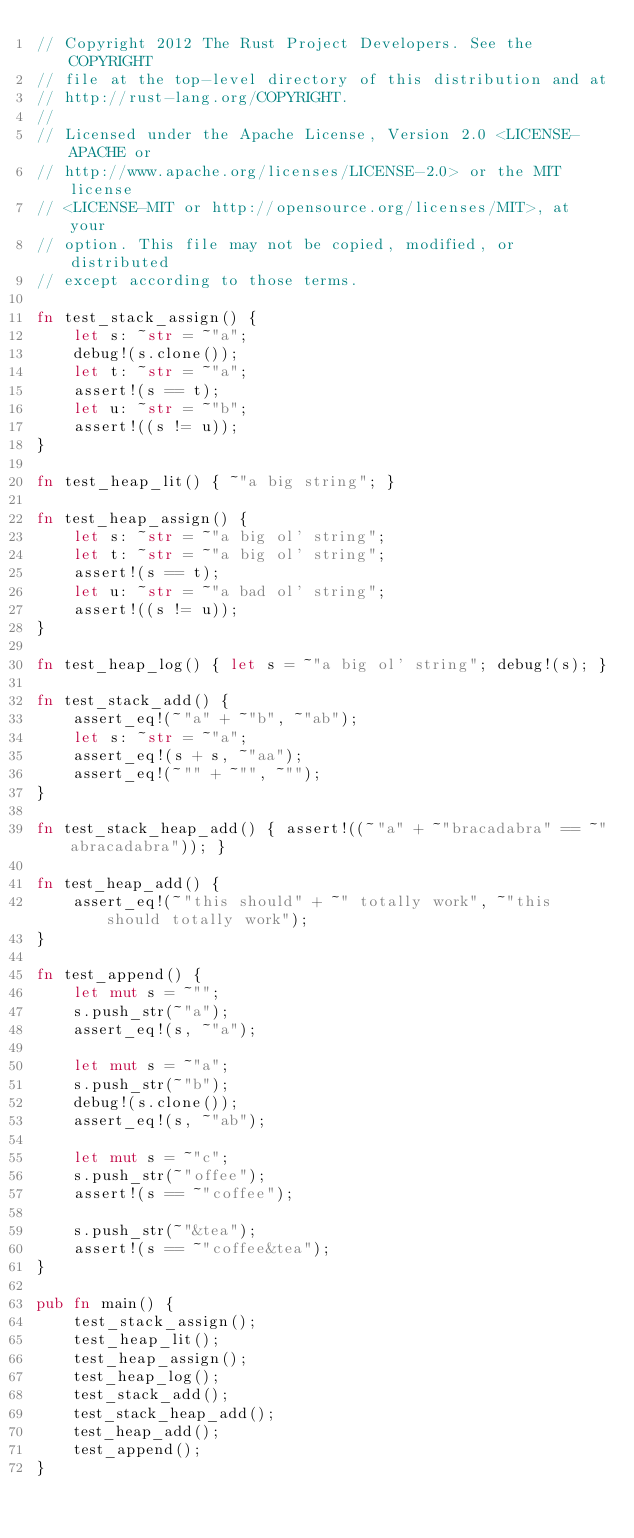Convert code to text. <code><loc_0><loc_0><loc_500><loc_500><_Rust_>// Copyright 2012 The Rust Project Developers. See the COPYRIGHT
// file at the top-level directory of this distribution and at
// http://rust-lang.org/COPYRIGHT.
//
// Licensed under the Apache License, Version 2.0 <LICENSE-APACHE or
// http://www.apache.org/licenses/LICENSE-2.0> or the MIT license
// <LICENSE-MIT or http://opensource.org/licenses/MIT>, at your
// option. This file may not be copied, modified, or distributed
// except according to those terms.

fn test_stack_assign() {
    let s: ~str = ~"a";
    debug!(s.clone());
    let t: ~str = ~"a";
    assert!(s == t);
    let u: ~str = ~"b";
    assert!((s != u));
}

fn test_heap_lit() { ~"a big string"; }

fn test_heap_assign() {
    let s: ~str = ~"a big ol' string";
    let t: ~str = ~"a big ol' string";
    assert!(s == t);
    let u: ~str = ~"a bad ol' string";
    assert!((s != u));
}

fn test_heap_log() { let s = ~"a big ol' string"; debug!(s); }

fn test_stack_add() {
    assert_eq!(~"a" + ~"b", ~"ab");
    let s: ~str = ~"a";
    assert_eq!(s + s, ~"aa");
    assert_eq!(~"" + ~"", ~"");
}

fn test_stack_heap_add() { assert!((~"a" + ~"bracadabra" == ~"abracadabra")); }

fn test_heap_add() {
    assert_eq!(~"this should" + ~" totally work", ~"this should totally work");
}

fn test_append() {
    let mut s = ~"";
    s.push_str(~"a");
    assert_eq!(s, ~"a");

    let mut s = ~"a";
    s.push_str(~"b");
    debug!(s.clone());
    assert_eq!(s, ~"ab");

    let mut s = ~"c";
    s.push_str(~"offee");
    assert!(s == ~"coffee");

    s.push_str(~"&tea");
    assert!(s == ~"coffee&tea");
}

pub fn main() {
    test_stack_assign();
    test_heap_lit();
    test_heap_assign();
    test_heap_log();
    test_stack_add();
    test_stack_heap_add();
    test_heap_add();
    test_append();
}
</code> 